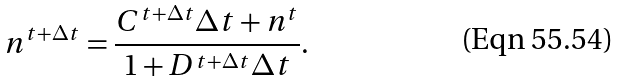Convert formula to latex. <formula><loc_0><loc_0><loc_500><loc_500>n ^ { t + \Delta t } = \frac { C ^ { t + \Delta t } \Delta t + n ^ { t } } { 1 + D ^ { t + \Delta t } \Delta t } .</formula> 